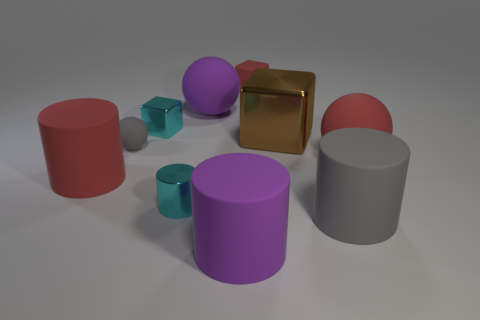What time of day does this lighting remind you of? The soft and even lighting in the image is reminiscent of early morning or late afternoon, where the sunlight is gentle, creating soft shadows. It lacks the intensity and directionality that you would see from the sun at its peak. 